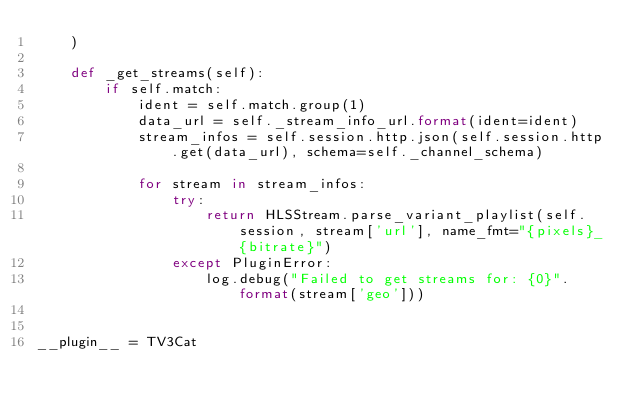<code> <loc_0><loc_0><loc_500><loc_500><_Python_>    )

    def _get_streams(self):
        if self.match:
            ident = self.match.group(1)
            data_url = self._stream_info_url.format(ident=ident)
            stream_infos = self.session.http.json(self.session.http.get(data_url), schema=self._channel_schema)

            for stream in stream_infos:
                try:
                    return HLSStream.parse_variant_playlist(self.session, stream['url'], name_fmt="{pixels}_{bitrate}")
                except PluginError:
                    log.debug("Failed to get streams for: {0}".format(stream['geo']))


__plugin__ = TV3Cat
</code> 